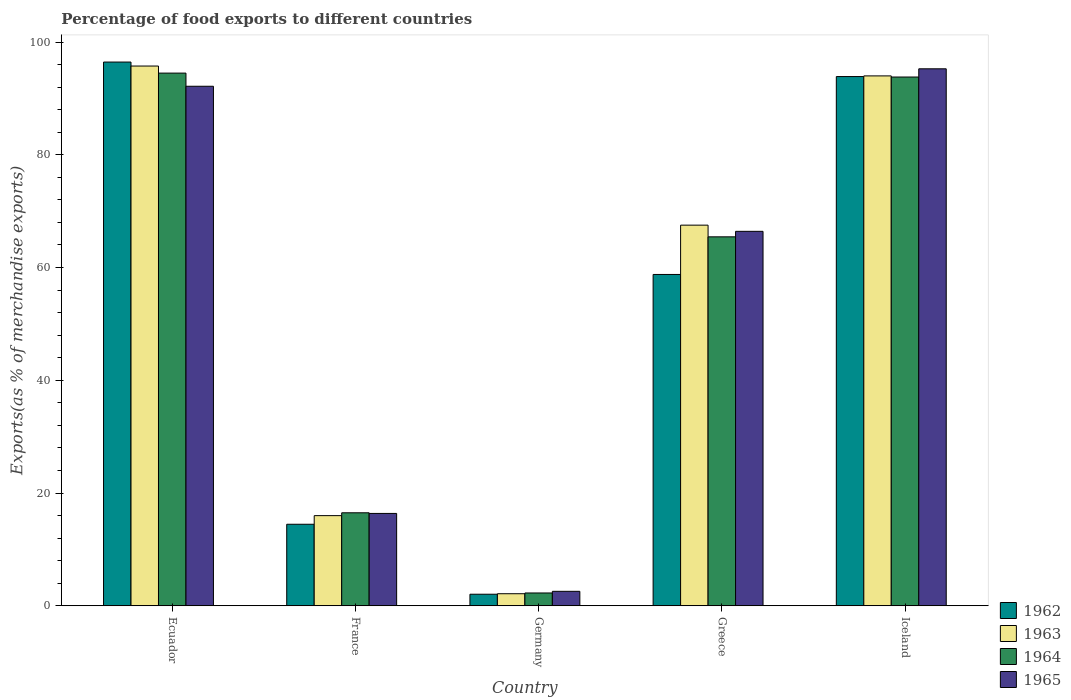How many different coloured bars are there?
Keep it short and to the point. 4. Are the number of bars on each tick of the X-axis equal?
Keep it short and to the point. Yes. How many bars are there on the 1st tick from the left?
Your answer should be very brief. 4. What is the percentage of exports to different countries in 1962 in Germany?
Your response must be concise. 2.05. Across all countries, what is the maximum percentage of exports to different countries in 1964?
Your response must be concise. 94.49. Across all countries, what is the minimum percentage of exports to different countries in 1964?
Your answer should be very brief. 2.27. In which country was the percentage of exports to different countries in 1962 maximum?
Offer a very short reply. Ecuador. In which country was the percentage of exports to different countries in 1962 minimum?
Make the answer very short. Germany. What is the total percentage of exports to different countries in 1962 in the graph?
Your response must be concise. 265.61. What is the difference between the percentage of exports to different countries in 1962 in France and that in Greece?
Provide a succinct answer. -44.31. What is the difference between the percentage of exports to different countries in 1962 in France and the percentage of exports to different countries in 1965 in Iceland?
Offer a terse response. -80.79. What is the average percentage of exports to different countries in 1962 per country?
Provide a short and direct response. 53.12. What is the difference between the percentage of exports to different countries of/in 1963 and percentage of exports to different countries of/in 1965 in Iceland?
Ensure brevity in your answer.  -1.26. What is the ratio of the percentage of exports to different countries in 1964 in Greece to that in Iceland?
Offer a very short reply. 0.7. Is the percentage of exports to different countries in 1962 in Ecuador less than that in Greece?
Ensure brevity in your answer.  No. What is the difference between the highest and the second highest percentage of exports to different countries in 1964?
Give a very brief answer. -28.35. What is the difference between the highest and the lowest percentage of exports to different countries in 1963?
Keep it short and to the point. 93.6. In how many countries, is the percentage of exports to different countries in 1964 greater than the average percentage of exports to different countries in 1964 taken over all countries?
Offer a very short reply. 3. Is it the case that in every country, the sum of the percentage of exports to different countries in 1965 and percentage of exports to different countries in 1963 is greater than the sum of percentage of exports to different countries in 1962 and percentage of exports to different countries in 1964?
Provide a succinct answer. No. What does the 3rd bar from the left in Germany represents?
Make the answer very short. 1964. What does the 1st bar from the right in Germany represents?
Make the answer very short. 1965. Is it the case that in every country, the sum of the percentage of exports to different countries in 1962 and percentage of exports to different countries in 1965 is greater than the percentage of exports to different countries in 1963?
Keep it short and to the point. Yes. Are all the bars in the graph horizontal?
Offer a terse response. No. What is the difference between two consecutive major ticks on the Y-axis?
Keep it short and to the point. 20. Does the graph contain any zero values?
Give a very brief answer. No. Where does the legend appear in the graph?
Make the answer very short. Bottom right. How are the legend labels stacked?
Ensure brevity in your answer.  Vertical. What is the title of the graph?
Your response must be concise. Percentage of food exports to different countries. What is the label or title of the Y-axis?
Give a very brief answer. Exports(as % of merchandise exports). What is the Exports(as % of merchandise exports) in 1962 in Ecuador?
Make the answer very short. 96.45. What is the Exports(as % of merchandise exports) in 1963 in Ecuador?
Offer a terse response. 95.74. What is the Exports(as % of merchandise exports) of 1964 in Ecuador?
Make the answer very short. 94.49. What is the Exports(as % of merchandise exports) of 1965 in Ecuador?
Provide a short and direct response. 92.15. What is the Exports(as % of merchandise exports) in 1962 in France?
Offer a terse response. 14.46. What is the Exports(as % of merchandise exports) in 1963 in France?
Offer a terse response. 15.99. What is the Exports(as % of merchandise exports) in 1964 in France?
Offer a terse response. 16.5. What is the Exports(as % of merchandise exports) in 1965 in France?
Give a very brief answer. 16.38. What is the Exports(as % of merchandise exports) of 1962 in Germany?
Make the answer very short. 2.05. What is the Exports(as % of merchandise exports) in 1963 in Germany?
Keep it short and to the point. 2.14. What is the Exports(as % of merchandise exports) of 1964 in Germany?
Offer a very short reply. 2.27. What is the Exports(as % of merchandise exports) in 1965 in Germany?
Offer a very short reply. 2.57. What is the Exports(as % of merchandise exports) of 1962 in Greece?
Provide a short and direct response. 58.77. What is the Exports(as % of merchandise exports) of 1963 in Greece?
Ensure brevity in your answer.  67.52. What is the Exports(as % of merchandise exports) of 1964 in Greece?
Provide a short and direct response. 65.45. What is the Exports(as % of merchandise exports) of 1965 in Greece?
Your answer should be compact. 66.42. What is the Exports(as % of merchandise exports) of 1962 in Iceland?
Ensure brevity in your answer.  93.87. What is the Exports(as % of merchandise exports) of 1963 in Iceland?
Give a very brief answer. 93.99. What is the Exports(as % of merchandise exports) in 1964 in Iceland?
Provide a succinct answer. 93.79. What is the Exports(as % of merchandise exports) of 1965 in Iceland?
Give a very brief answer. 95.25. Across all countries, what is the maximum Exports(as % of merchandise exports) of 1962?
Give a very brief answer. 96.45. Across all countries, what is the maximum Exports(as % of merchandise exports) in 1963?
Your answer should be compact. 95.74. Across all countries, what is the maximum Exports(as % of merchandise exports) of 1964?
Provide a short and direct response. 94.49. Across all countries, what is the maximum Exports(as % of merchandise exports) in 1965?
Your answer should be compact. 95.25. Across all countries, what is the minimum Exports(as % of merchandise exports) of 1962?
Provide a succinct answer. 2.05. Across all countries, what is the minimum Exports(as % of merchandise exports) in 1963?
Your response must be concise. 2.14. Across all countries, what is the minimum Exports(as % of merchandise exports) in 1964?
Give a very brief answer. 2.27. Across all countries, what is the minimum Exports(as % of merchandise exports) in 1965?
Give a very brief answer. 2.57. What is the total Exports(as % of merchandise exports) of 1962 in the graph?
Give a very brief answer. 265.61. What is the total Exports(as % of merchandise exports) of 1963 in the graph?
Provide a succinct answer. 275.38. What is the total Exports(as % of merchandise exports) in 1964 in the graph?
Make the answer very short. 272.49. What is the total Exports(as % of merchandise exports) in 1965 in the graph?
Keep it short and to the point. 272.78. What is the difference between the Exports(as % of merchandise exports) of 1962 in Ecuador and that in France?
Give a very brief answer. 81.98. What is the difference between the Exports(as % of merchandise exports) in 1963 in Ecuador and that in France?
Your response must be concise. 79.75. What is the difference between the Exports(as % of merchandise exports) in 1964 in Ecuador and that in France?
Give a very brief answer. 77.99. What is the difference between the Exports(as % of merchandise exports) of 1965 in Ecuador and that in France?
Offer a very short reply. 75.77. What is the difference between the Exports(as % of merchandise exports) of 1962 in Ecuador and that in Germany?
Offer a terse response. 94.39. What is the difference between the Exports(as % of merchandise exports) in 1963 in Ecuador and that in Germany?
Offer a terse response. 93.6. What is the difference between the Exports(as % of merchandise exports) of 1964 in Ecuador and that in Germany?
Your answer should be compact. 92.21. What is the difference between the Exports(as % of merchandise exports) in 1965 in Ecuador and that in Germany?
Provide a short and direct response. 89.59. What is the difference between the Exports(as % of merchandise exports) in 1962 in Ecuador and that in Greece?
Provide a short and direct response. 37.67. What is the difference between the Exports(as % of merchandise exports) in 1963 in Ecuador and that in Greece?
Give a very brief answer. 28.22. What is the difference between the Exports(as % of merchandise exports) of 1964 in Ecuador and that in Greece?
Your answer should be compact. 29.04. What is the difference between the Exports(as % of merchandise exports) of 1965 in Ecuador and that in Greece?
Give a very brief answer. 25.73. What is the difference between the Exports(as % of merchandise exports) in 1962 in Ecuador and that in Iceland?
Offer a very short reply. 2.57. What is the difference between the Exports(as % of merchandise exports) of 1963 in Ecuador and that in Iceland?
Offer a very short reply. 1.75. What is the difference between the Exports(as % of merchandise exports) of 1964 in Ecuador and that in Iceland?
Give a very brief answer. 0.7. What is the difference between the Exports(as % of merchandise exports) in 1965 in Ecuador and that in Iceland?
Your answer should be very brief. -3.1. What is the difference between the Exports(as % of merchandise exports) in 1962 in France and that in Germany?
Your response must be concise. 12.41. What is the difference between the Exports(as % of merchandise exports) of 1963 in France and that in Germany?
Provide a succinct answer. 13.85. What is the difference between the Exports(as % of merchandise exports) of 1964 in France and that in Germany?
Your response must be concise. 14.22. What is the difference between the Exports(as % of merchandise exports) in 1965 in France and that in Germany?
Ensure brevity in your answer.  13.82. What is the difference between the Exports(as % of merchandise exports) of 1962 in France and that in Greece?
Your answer should be very brief. -44.31. What is the difference between the Exports(as % of merchandise exports) of 1963 in France and that in Greece?
Offer a very short reply. -51.53. What is the difference between the Exports(as % of merchandise exports) in 1964 in France and that in Greece?
Ensure brevity in your answer.  -48.95. What is the difference between the Exports(as % of merchandise exports) of 1965 in France and that in Greece?
Give a very brief answer. -50.04. What is the difference between the Exports(as % of merchandise exports) of 1962 in France and that in Iceland?
Make the answer very short. -79.41. What is the difference between the Exports(as % of merchandise exports) in 1963 in France and that in Iceland?
Your response must be concise. -78. What is the difference between the Exports(as % of merchandise exports) in 1964 in France and that in Iceland?
Make the answer very short. -77.29. What is the difference between the Exports(as % of merchandise exports) of 1965 in France and that in Iceland?
Provide a succinct answer. -78.87. What is the difference between the Exports(as % of merchandise exports) in 1962 in Germany and that in Greece?
Your answer should be very brief. -56.72. What is the difference between the Exports(as % of merchandise exports) of 1963 in Germany and that in Greece?
Give a very brief answer. -65.38. What is the difference between the Exports(as % of merchandise exports) of 1964 in Germany and that in Greece?
Your answer should be very brief. -63.17. What is the difference between the Exports(as % of merchandise exports) of 1965 in Germany and that in Greece?
Your answer should be compact. -63.85. What is the difference between the Exports(as % of merchandise exports) in 1962 in Germany and that in Iceland?
Ensure brevity in your answer.  -91.82. What is the difference between the Exports(as % of merchandise exports) of 1963 in Germany and that in Iceland?
Provide a succinct answer. -91.85. What is the difference between the Exports(as % of merchandise exports) in 1964 in Germany and that in Iceland?
Your response must be concise. -91.52. What is the difference between the Exports(as % of merchandise exports) of 1965 in Germany and that in Iceland?
Your answer should be compact. -92.68. What is the difference between the Exports(as % of merchandise exports) in 1962 in Greece and that in Iceland?
Your response must be concise. -35.1. What is the difference between the Exports(as % of merchandise exports) of 1963 in Greece and that in Iceland?
Ensure brevity in your answer.  -26.47. What is the difference between the Exports(as % of merchandise exports) in 1964 in Greece and that in Iceland?
Provide a short and direct response. -28.35. What is the difference between the Exports(as % of merchandise exports) in 1965 in Greece and that in Iceland?
Your response must be concise. -28.83. What is the difference between the Exports(as % of merchandise exports) in 1962 in Ecuador and the Exports(as % of merchandise exports) in 1963 in France?
Offer a very short reply. 80.45. What is the difference between the Exports(as % of merchandise exports) in 1962 in Ecuador and the Exports(as % of merchandise exports) in 1964 in France?
Your answer should be compact. 79.95. What is the difference between the Exports(as % of merchandise exports) in 1962 in Ecuador and the Exports(as % of merchandise exports) in 1965 in France?
Provide a short and direct response. 80.06. What is the difference between the Exports(as % of merchandise exports) of 1963 in Ecuador and the Exports(as % of merchandise exports) of 1964 in France?
Make the answer very short. 79.24. What is the difference between the Exports(as % of merchandise exports) of 1963 in Ecuador and the Exports(as % of merchandise exports) of 1965 in France?
Keep it short and to the point. 79.36. What is the difference between the Exports(as % of merchandise exports) in 1964 in Ecuador and the Exports(as % of merchandise exports) in 1965 in France?
Make the answer very short. 78.1. What is the difference between the Exports(as % of merchandise exports) in 1962 in Ecuador and the Exports(as % of merchandise exports) in 1963 in Germany?
Offer a terse response. 94.31. What is the difference between the Exports(as % of merchandise exports) of 1962 in Ecuador and the Exports(as % of merchandise exports) of 1964 in Germany?
Your answer should be compact. 94.17. What is the difference between the Exports(as % of merchandise exports) in 1962 in Ecuador and the Exports(as % of merchandise exports) in 1965 in Germany?
Offer a very short reply. 93.88. What is the difference between the Exports(as % of merchandise exports) of 1963 in Ecuador and the Exports(as % of merchandise exports) of 1964 in Germany?
Your response must be concise. 93.46. What is the difference between the Exports(as % of merchandise exports) of 1963 in Ecuador and the Exports(as % of merchandise exports) of 1965 in Germany?
Give a very brief answer. 93.17. What is the difference between the Exports(as % of merchandise exports) in 1964 in Ecuador and the Exports(as % of merchandise exports) in 1965 in Germany?
Ensure brevity in your answer.  91.92. What is the difference between the Exports(as % of merchandise exports) of 1962 in Ecuador and the Exports(as % of merchandise exports) of 1963 in Greece?
Ensure brevity in your answer.  28.93. What is the difference between the Exports(as % of merchandise exports) in 1962 in Ecuador and the Exports(as % of merchandise exports) in 1964 in Greece?
Provide a succinct answer. 31. What is the difference between the Exports(as % of merchandise exports) in 1962 in Ecuador and the Exports(as % of merchandise exports) in 1965 in Greece?
Give a very brief answer. 30.02. What is the difference between the Exports(as % of merchandise exports) in 1963 in Ecuador and the Exports(as % of merchandise exports) in 1964 in Greece?
Make the answer very short. 30.29. What is the difference between the Exports(as % of merchandise exports) in 1963 in Ecuador and the Exports(as % of merchandise exports) in 1965 in Greece?
Make the answer very short. 29.32. What is the difference between the Exports(as % of merchandise exports) in 1964 in Ecuador and the Exports(as % of merchandise exports) in 1965 in Greece?
Provide a short and direct response. 28.07. What is the difference between the Exports(as % of merchandise exports) of 1962 in Ecuador and the Exports(as % of merchandise exports) of 1963 in Iceland?
Offer a terse response. 2.45. What is the difference between the Exports(as % of merchandise exports) in 1962 in Ecuador and the Exports(as % of merchandise exports) in 1964 in Iceland?
Your response must be concise. 2.65. What is the difference between the Exports(as % of merchandise exports) in 1962 in Ecuador and the Exports(as % of merchandise exports) in 1965 in Iceland?
Give a very brief answer. 1.2. What is the difference between the Exports(as % of merchandise exports) in 1963 in Ecuador and the Exports(as % of merchandise exports) in 1964 in Iceland?
Your answer should be very brief. 1.95. What is the difference between the Exports(as % of merchandise exports) of 1963 in Ecuador and the Exports(as % of merchandise exports) of 1965 in Iceland?
Offer a very short reply. 0.49. What is the difference between the Exports(as % of merchandise exports) of 1964 in Ecuador and the Exports(as % of merchandise exports) of 1965 in Iceland?
Ensure brevity in your answer.  -0.76. What is the difference between the Exports(as % of merchandise exports) in 1962 in France and the Exports(as % of merchandise exports) in 1963 in Germany?
Give a very brief answer. 12.32. What is the difference between the Exports(as % of merchandise exports) of 1962 in France and the Exports(as % of merchandise exports) of 1964 in Germany?
Offer a very short reply. 12.19. What is the difference between the Exports(as % of merchandise exports) in 1962 in France and the Exports(as % of merchandise exports) in 1965 in Germany?
Give a very brief answer. 11.9. What is the difference between the Exports(as % of merchandise exports) of 1963 in France and the Exports(as % of merchandise exports) of 1964 in Germany?
Keep it short and to the point. 13.72. What is the difference between the Exports(as % of merchandise exports) of 1963 in France and the Exports(as % of merchandise exports) of 1965 in Germany?
Provide a succinct answer. 13.42. What is the difference between the Exports(as % of merchandise exports) of 1964 in France and the Exports(as % of merchandise exports) of 1965 in Germany?
Your answer should be compact. 13.93. What is the difference between the Exports(as % of merchandise exports) in 1962 in France and the Exports(as % of merchandise exports) in 1963 in Greece?
Offer a terse response. -53.05. What is the difference between the Exports(as % of merchandise exports) of 1962 in France and the Exports(as % of merchandise exports) of 1964 in Greece?
Give a very brief answer. -50.98. What is the difference between the Exports(as % of merchandise exports) of 1962 in France and the Exports(as % of merchandise exports) of 1965 in Greece?
Provide a succinct answer. -51.96. What is the difference between the Exports(as % of merchandise exports) in 1963 in France and the Exports(as % of merchandise exports) in 1964 in Greece?
Give a very brief answer. -49.45. What is the difference between the Exports(as % of merchandise exports) of 1963 in France and the Exports(as % of merchandise exports) of 1965 in Greece?
Ensure brevity in your answer.  -50.43. What is the difference between the Exports(as % of merchandise exports) in 1964 in France and the Exports(as % of merchandise exports) in 1965 in Greece?
Your answer should be very brief. -49.93. What is the difference between the Exports(as % of merchandise exports) in 1962 in France and the Exports(as % of merchandise exports) in 1963 in Iceland?
Ensure brevity in your answer.  -79.53. What is the difference between the Exports(as % of merchandise exports) of 1962 in France and the Exports(as % of merchandise exports) of 1964 in Iceland?
Your answer should be compact. -79.33. What is the difference between the Exports(as % of merchandise exports) of 1962 in France and the Exports(as % of merchandise exports) of 1965 in Iceland?
Provide a short and direct response. -80.79. What is the difference between the Exports(as % of merchandise exports) in 1963 in France and the Exports(as % of merchandise exports) in 1964 in Iceland?
Your answer should be very brief. -77.8. What is the difference between the Exports(as % of merchandise exports) of 1963 in France and the Exports(as % of merchandise exports) of 1965 in Iceland?
Your answer should be compact. -79.26. What is the difference between the Exports(as % of merchandise exports) in 1964 in France and the Exports(as % of merchandise exports) in 1965 in Iceland?
Keep it short and to the point. -78.75. What is the difference between the Exports(as % of merchandise exports) in 1962 in Germany and the Exports(as % of merchandise exports) in 1963 in Greece?
Offer a terse response. -65.47. What is the difference between the Exports(as % of merchandise exports) of 1962 in Germany and the Exports(as % of merchandise exports) of 1964 in Greece?
Provide a succinct answer. -63.39. What is the difference between the Exports(as % of merchandise exports) of 1962 in Germany and the Exports(as % of merchandise exports) of 1965 in Greece?
Provide a short and direct response. -64.37. What is the difference between the Exports(as % of merchandise exports) in 1963 in Germany and the Exports(as % of merchandise exports) in 1964 in Greece?
Provide a short and direct response. -63.31. What is the difference between the Exports(as % of merchandise exports) of 1963 in Germany and the Exports(as % of merchandise exports) of 1965 in Greece?
Make the answer very short. -64.28. What is the difference between the Exports(as % of merchandise exports) of 1964 in Germany and the Exports(as % of merchandise exports) of 1965 in Greece?
Offer a very short reply. -64.15. What is the difference between the Exports(as % of merchandise exports) in 1962 in Germany and the Exports(as % of merchandise exports) in 1963 in Iceland?
Make the answer very short. -91.94. What is the difference between the Exports(as % of merchandise exports) of 1962 in Germany and the Exports(as % of merchandise exports) of 1964 in Iceland?
Offer a very short reply. -91.74. What is the difference between the Exports(as % of merchandise exports) of 1962 in Germany and the Exports(as % of merchandise exports) of 1965 in Iceland?
Provide a succinct answer. -93.2. What is the difference between the Exports(as % of merchandise exports) of 1963 in Germany and the Exports(as % of merchandise exports) of 1964 in Iceland?
Offer a terse response. -91.65. What is the difference between the Exports(as % of merchandise exports) in 1963 in Germany and the Exports(as % of merchandise exports) in 1965 in Iceland?
Your response must be concise. -93.11. What is the difference between the Exports(as % of merchandise exports) of 1964 in Germany and the Exports(as % of merchandise exports) of 1965 in Iceland?
Your answer should be very brief. -92.98. What is the difference between the Exports(as % of merchandise exports) of 1962 in Greece and the Exports(as % of merchandise exports) of 1963 in Iceland?
Ensure brevity in your answer.  -35.22. What is the difference between the Exports(as % of merchandise exports) in 1962 in Greece and the Exports(as % of merchandise exports) in 1964 in Iceland?
Keep it short and to the point. -35.02. What is the difference between the Exports(as % of merchandise exports) in 1962 in Greece and the Exports(as % of merchandise exports) in 1965 in Iceland?
Your answer should be very brief. -36.48. What is the difference between the Exports(as % of merchandise exports) of 1963 in Greece and the Exports(as % of merchandise exports) of 1964 in Iceland?
Make the answer very short. -26.27. What is the difference between the Exports(as % of merchandise exports) in 1963 in Greece and the Exports(as % of merchandise exports) in 1965 in Iceland?
Give a very brief answer. -27.73. What is the difference between the Exports(as % of merchandise exports) in 1964 in Greece and the Exports(as % of merchandise exports) in 1965 in Iceland?
Make the answer very short. -29.8. What is the average Exports(as % of merchandise exports) of 1962 per country?
Your answer should be very brief. 53.12. What is the average Exports(as % of merchandise exports) of 1963 per country?
Give a very brief answer. 55.08. What is the average Exports(as % of merchandise exports) of 1964 per country?
Keep it short and to the point. 54.5. What is the average Exports(as % of merchandise exports) of 1965 per country?
Make the answer very short. 54.56. What is the difference between the Exports(as % of merchandise exports) in 1962 and Exports(as % of merchandise exports) in 1963 in Ecuador?
Provide a short and direct response. 0.71. What is the difference between the Exports(as % of merchandise exports) in 1962 and Exports(as % of merchandise exports) in 1964 in Ecuador?
Your response must be concise. 1.96. What is the difference between the Exports(as % of merchandise exports) of 1962 and Exports(as % of merchandise exports) of 1965 in Ecuador?
Give a very brief answer. 4.29. What is the difference between the Exports(as % of merchandise exports) in 1963 and Exports(as % of merchandise exports) in 1964 in Ecuador?
Make the answer very short. 1.25. What is the difference between the Exports(as % of merchandise exports) of 1963 and Exports(as % of merchandise exports) of 1965 in Ecuador?
Ensure brevity in your answer.  3.58. What is the difference between the Exports(as % of merchandise exports) of 1964 and Exports(as % of merchandise exports) of 1965 in Ecuador?
Your response must be concise. 2.33. What is the difference between the Exports(as % of merchandise exports) in 1962 and Exports(as % of merchandise exports) in 1963 in France?
Give a very brief answer. -1.53. What is the difference between the Exports(as % of merchandise exports) in 1962 and Exports(as % of merchandise exports) in 1964 in France?
Ensure brevity in your answer.  -2.03. What is the difference between the Exports(as % of merchandise exports) of 1962 and Exports(as % of merchandise exports) of 1965 in France?
Offer a very short reply. -1.92. What is the difference between the Exports(as % of merchandise exports) in 1963 and Exports(as % of merchandise exports) in 1964 in France?
Offer a terse response. -0.5. What is the difference between the Exports(as % of merchandise exports) in 1963 and Exports(as % of merchandise exports) in 1965 in France?
Offer a terse response. -0.39. What is the difference between the Exports(as % of merchandise exports) in 1964 and Exports(as % of merchandise exports) in 1965 in France?
Provide a succinct answer. 0.11. What is the difference between the Exports(as % of merchandise exports) in 1962 and Exports(as % of merchandise exports) in 1963 in Germany?
Your answer should be very brief. -0.09. What is the difference between the Exports(as % of merchandise exports) of 1962 and Exports(as % of merchandise exports) of 1964 in Germany?
Keep it short and to the point. -0.22. What is the difference between the Exports(as % of merchandise exports) of 1962 and Exports(as % of merchandise exports) of 1965 in Germany?
Offer a very short reply. -0.52. What is the difference between the Exports(as % of merchandise exports) of 1963 and Exports(as % of merchandise exports) of 1964 in Germany?
Your response must be concise. -0.14. What is the difference between the Exports(as % of merchandise exports) in 1963 and Exports(as % of merchandise exports) in 1965 in Germany?
Offer a terse response. -0.43. What is the difference between the Exports(as % of merchandise exports) of 1964 and Exports(as % of merchandise exports) of 1965 in Germany?
Provide a succinct answer. -0.29. What is the difference between the Exports(as % of merchandise exports) in 1962 and Exports(as % of merchandise exports) in 1963 in Greece?
Offer a very short reply. -8.75. What is the difference between the Exports(as % of merchandise exports) of 1962 and Exports(as % of merchandise exports) of 1964 in Greece?
Your answer should be very brief. -6.67. What is the difference between the Exports(as % of merchandise exports) of 1962 and Exports(as % of merchandise exports) of 1965 in Greece?
Keep it short and to the point. -7.65. What is the difference between the Exports(as % of merchandise exports) of 1963 and Exports(as % of merchandise exports) of 1964 in Greece?
Provide a short and direct response. 2.07. What is the difference between the Exports(as % of merchandise exports) of 1963 and Exports(as % of merchandise exports) of 1965 in Greece?
Your response must be concise. 1.1. What is the difference between the Exports(as % of merchandise exports) of 1964 and Exports(as % of merchandise exports) of 1965 in Greece?
Your answer should be compact. -0.98. What is the difference between the Exports(as % of merchandise exports) of 1962 and Exports(as % of merchandise exports) of 1963 in Iceland?
Give a very brief answer. -0.12. What is the difference between the Exports(as % of merchandise exports) in 1962 and Exports(as % of merchandise exports) in 1964 in Iceland?
Give a very brief answer. 0.08. What is the difference between the Exports(as % of merchandise exports) of 1962 and Exports(as % of merchandise exports) of 1965 in Iceland?
Your answer should be very brief. -1.38. What is the difference between the Exports(as % of merchandise exports) in 1963 and Exports(as % of merchandise exports) in 1964 in Iceland?
Keep it short and to the point. 0.2. What is the difference between the Exports(as % of merchandise exports) of 1963 and Exports(as % of merchandise exports) of 1965 in Iceland?
Your answer should be very brief. -1.26. What is the difference between the Exports(as % of merchandise exports) in 1964 and Exports(as % of merchandise exports) in 1965 in Iceland?
Keep it short and to the point. -1.46. What is the ratio of the Exports(as % of merchandise exports) in 1962 in Ecuador to that in France?
Keep it short and to the point. 6.67. What is the ratio of the Exports(as % of merchandise exports) in 1963 in Ecuador to that in France?
Your response must be concise. 5.99. What is the ratio of the Exports(as % of merchandise exports) in 1964 in Ecuador to that in France?
Offer a very short reply. 5.73. What is the ratio of the Exports(as % of merchandise exports) in 1965 in Ecuador to that in France?
Give a very brief answer. 5.62. What is the ratio of the Exports(as % of merchandise exports) of 1962 in Ecuador to that in Germany?
Ensure brevity in your answer.  47.01. What is the ratio of the Exports(as % of merchandise exports) of 1963 in Ecuador to that in Germany?
Give a very brief answer. 44.76. What is the ratio of the Exports(as % of merchandise exports) in 1964 in Ecuador to that in Germany?
Keep it short and to the point. 41.54. What is the ratio of the Exports(as % of merchandise exports) in 1965 in Ecuador to that in Germany?
Keep it short and to the point. 35.89. What is the ratio of the Exports(as % of merchandise exports) of 1962 in Ecuador to that in Greece?
Your response must be concise. 1.64. What is the ratio of the Exports(as % of merchandise exports) in 1963 in Ecuador to that in Greece?
Give a very brief answer. 1.42. What is the ratio of the Exports(as % of merchandise exports) of 1964 in Ecuador to that in Greece?
Give a very brief answer. 1.44. What is the ratio of the Exports(as % of merchandise exports) of 1965 in Ecuador to that in Greece?
Your answer should be compact. 1.39. What is the ratio of the Exports(as % of merchandise exports) in 1962 in Ecuador to that in Iceland?
Give a very brief answer. 1.03. What is the ratio of the Exports(as % of merchandise exports) in 1963 in Ecuador to that in Iceland?
Offer a terse response. 1.02. What is the ratio of the Exports(as % of merchandise exports) of 1964 in Ecuador to that in Iceland?
Offer a terse response. 1.01. What is the ratio of the Exports(as % of merchandise exports) in 1965 in Ecuador to that in Iceland?
Provide a succinct answer. 0.97. What is the ratio of the Exports(as % of merchandise exports) of 1962 in France to that in Germany?
Offer a terse response. 7.05. What is the ratio of the Exports(as % of merchandise exports) of 1963 in France to that in Germany?
Ensure brevity in your answer.  7.48. What is the ratio of the Exports(as % of merchandise exports) of 1964 in France to that in Germany?
Keep it short and to the point. 7.25. What is the ratio of the Exports(as % of merchandise exports) of 1965 in France to that in Germany?
Offer a terse response. 6.38. What is the ratio of the Exports(as % of merchandise exports) in 1962 in France to that in Greece?
Provide a succinct answer. 0.25. What is the ratio of the Exports(as % of merchandise exports) of 1963 in France to that in Greece?
Provide a short and direct response. 0.24. What is the ratio of the Exports(as % of merchandise exports) in 1964 in France to that in Greece?
Your response must be concise. 0.25. What is the ratio of the Exports(as % of merchandise exports) in 1965 in France to that in Greece?
Ensure brevity in your answer.  0.25. What is the ratio of the Exports(as % of merchandise exports) of 1962 in France to that in Iceland?
Your answer should be compact. 0.15. What is the ratio of the Exports(as % of merchandise exports) in 1963 in France to that in Iceland?
Keep it short and to the point. 0.17. What is the ratio of the Exports(as % of merchandise exports) in 1964 in France to that in Iceland?
Your answer should be very brief. 0.18. What is the ratio of the Exports(as % of merchandise exports) of 1965 in France to that in Iceland?
Your response must be concise. 0.17. What is the ratio of the Exports(as % of merchandise exports) of 1962 in Germany to that in Greece?
Provide a short and direct response. 0.03. What is the ratio of the Exports(as % of merchandise exports) in 1963 in Germany to that in Greece?
Keep it short and to the point. 0.03. What is the ratio of the Exports(as % of merchandise exports) of 1964 in Germany to that in Greece?
Provide a succinct answer. 0.03. What is the ratio of the Exports(as % of merchandise exports) of 1965 in Germany to that in Greece?
Your answer should be very brief. 0.04. What is the ratio of the Exports(as % of merchandise exports) of 1962 in Germany to that in Iceland?
Provide a short and direct response. 0.02. What is the ratio of the Exports(as % of merchandise exports) in 1963 in Germany to that in Iceland?
Make the answer very short. 0.02. What is the ratio of the Exports(as % of merchandise exports) in 1964 in Germany to that in Iceland?
Provide a short and direct response. 0.02. What is the ratio of the Exports(as % of merchandise exports) of 1965 in Germany to that in Iceland?
Ensure brevity in your answer.  0.03. What is the ratio of the Exports(as % of merchandise exports) of 1962 in Greece to that in Iceland?
Provide a short and direct response. 0.63. What is the ratio of the Exports(as % of merchandise exports) of 1963 in Greece to that in Iceland?
Give a very brief answer. 0.72. What is the ratio of the Exports(as % of merchandise exports) of 1964 in Greece to that in Iceland?
Offer a very short reply. 0.7. What is the ratio of the Exports(as % of merchandise exports) of 1965 in Greece to that in Iceland?
Make the answer very short. 0.7. What is the difference between the highest and the second highest Exports(as % of merchandise exports) in 1962?
Your answer should be very brief. 2.57. What is the difference between the highest and the second highest Exports(as % of merchandise exports) in 1963?
Your response must be concise. 1.75. What is the difference between the highest and the second highest Exports(as % of merchandise exports) of 1964?
Ensure brevity in your answer.  0.7. What is the difference between the highest and the second highest Exports(as % of merchandise exports) in 1965?
Give a very brief answer. 3.1. What is the difference between the highest and the lowest Exports(as % of merchandise exports) in 1962?
Provide a short and direct response. 94.39. What is the difference between the highest and the lowest Exports(as % of merchandise exports) in 1963?
Your response must be concise. 93.6. What is the difference between the highest and the lowest Exports(as % of merchandise exports) in 1964?
Make the answer very short. 92.21. What is the difference between the highest and the lowest Exports(as % of merchandise exports) of 1965?
Give a very brief answer. 92.68. 